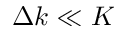Convert formula to latex. <formula><loc_0><loc_0><loc_500><loc_500>\Delta k \ll K</formula> 